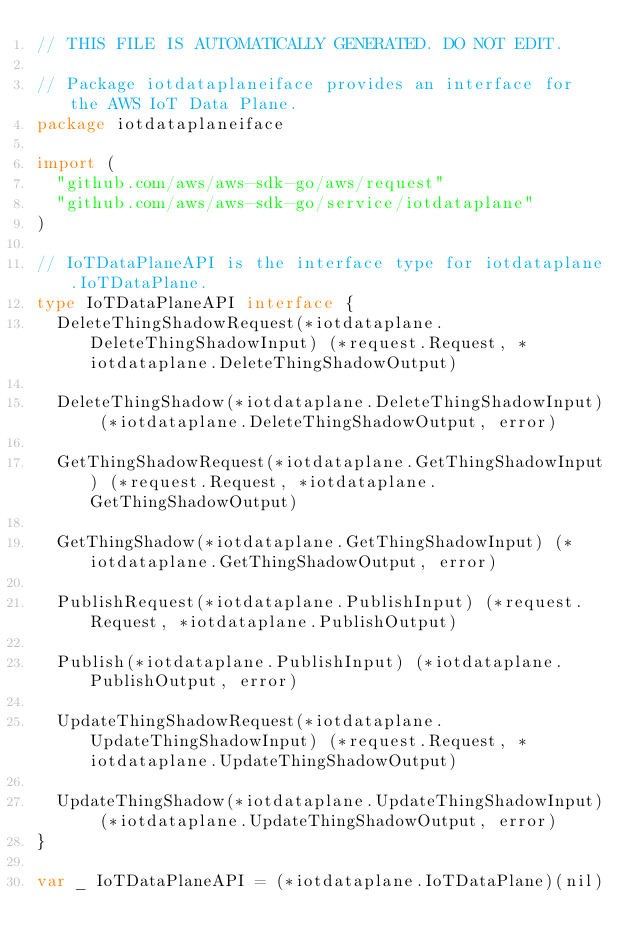<code> <loc_0><loc_0><loc_500><loc_500><_Go_>// THIS FILE IS AUTOMATICALLY GENERATED. DO NOT EDIT.

// Package iotdataplaneiface provides an interface for the AWS IoT Data Plane.
package iotdataplaneiface

import (
	"github.com/aws/aws-sdk-go/aws/request"
	"github.com/aws/aws-sdk-go/service/iotdataplane"
)

// IoTDataPlaneAPI is the interface type for iotdataplane.IoTDataPlane.
type IoTDataPlaneAPI interface {
	DeleteThingShadowRequest(*iotdataplane.DeleteThingShadowInput) (*request.Request, *iotdataplane.DeleteThingShadowOutput)

	DeleteThingShadow(*iotdataplane.DeleteThingShadowInput) (*iotdataplane.DeleteThingShadowOutput, error)

	GetThingShadowRequest(*iotdataplane.GetThingShadowInput) (*request.Request, *iotdataplane.GetThingShadowOutput)

	GetThingShadow(*iotdataplane.GetThingShadowInput) (*iotdataplane.GetThingShadowOutput, error)

	PublishRequest(*iotdataplane.PublishInput) (*request.Request, *iotdataplane.PublishOutput)

	Publish(*iotdataplane.PublishInput) (*iotdataplane.PublishOutput, error)

	UpdateThingShadowRequest(*iotdataplane.UpdateThingShadowInput) (*request.Request, *iotdataplane.UpdateThingShadowOutput)

	UpdateThingShadow(*iotdataplane.UpdateThingShadowInput) (*iotdataplane.UpdateThingShadowOutput, error)
}

var _ IoTDataPlaneAPI = (*iotdataplane.IoTDataPlane)(nil)
</code> 